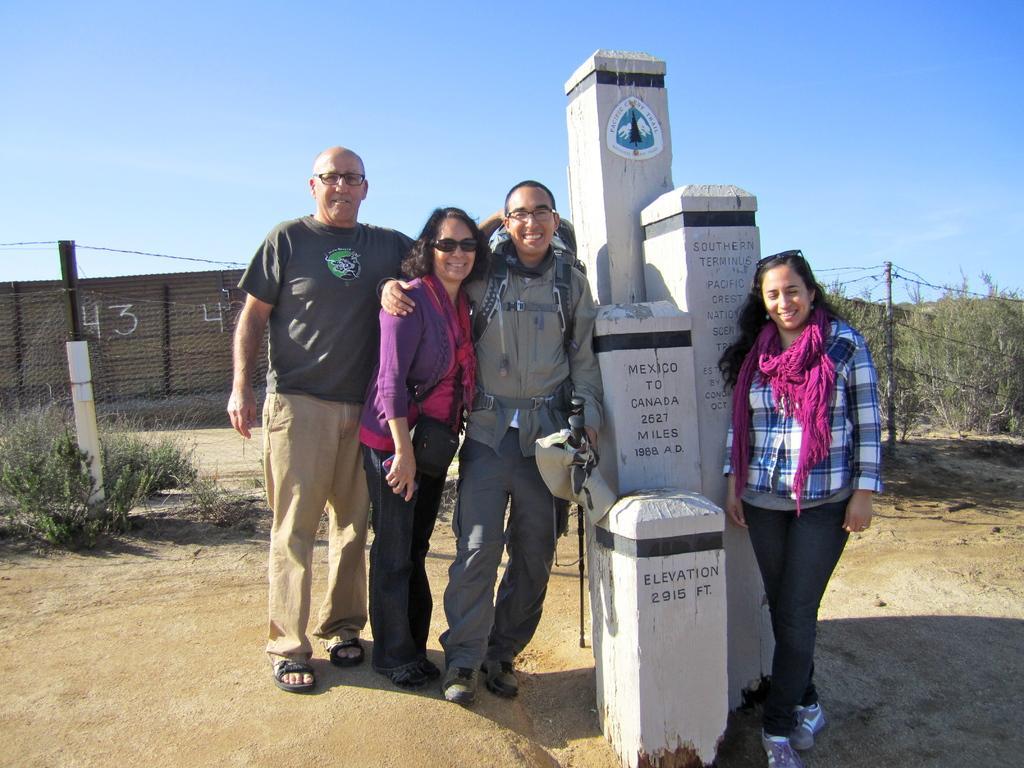In one or two sentences, can you explain what this image depicts? In this image there are three persons standing on the floor. Beside them there are stones. On the right side there is another woman standing on the floor who is wearing the scarf is also standing beside the stones. In the background there is a fence. Behind the fence there's a wall. At the top there is the sky. On the right side there are plants in the background. On the stones there is some text. 